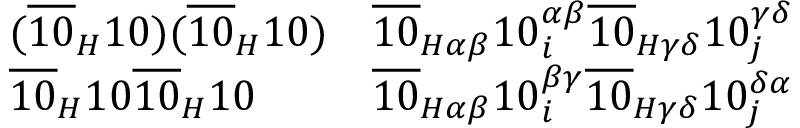<formula> <loc_0><loc_0><loc_500><loc_500>{ \begin{array} { l l } { ( { \overline { 1 0 } } _ { H } 1 0 ) ( { \overline { 1 0 } } _ { H } 1 0 ) } & { { \overline { 1 0 } } _ { H \alpha \beta } 1 0 _ { i } ^ { \alpha \beta } { \overline { 1 0 } } _ { H \gamma \delta } 1 0 _ { j } ^ { \gamma \delta } } \\ { { \overline { 1 0 } } _ { H } 1 0 { \overline { 1 0 } } _ { H } 1 0 } & { { \overline { 1 0 } } _ { H \alpha \beta } 1 0 _ { i } ^ { \beta \gamma } { \overline { 1 0 } } _ { H \gamma \delta } 1 0 _ { j } ^ { \delta \alpha } } \end{array} }</formula> 